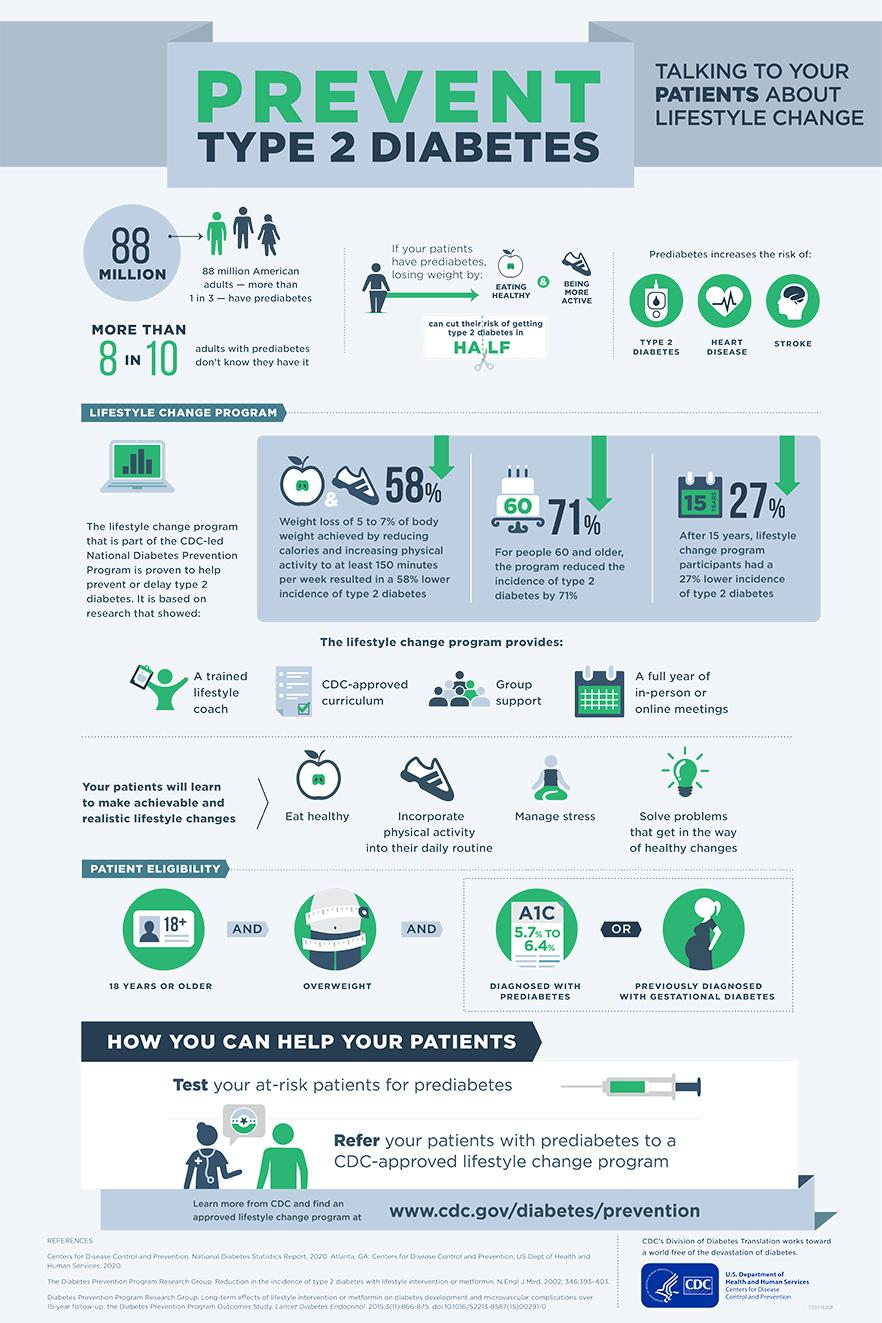Specify some key components in this picture. The A1C test is used to measure a person's average blood glucose levels over the previous three months, and the results of this test help to determine if a person has prediabetes. If a person has been diagnosed with prediabetes, the normal range of the A1C test is between 5.7% and 6.4%. A patient enrolled in the lifestyle change program may make a maximum of 4 changes. Approximately 58% of people can experience a reduction in the incidence of type 2 diabetes due to weight loss. Eating a healthy diet and being more physically active are two activities that can help individuals control their weight. Prediabetes poses a significant risk of developing type 2 diabetes, heart disease, and stroke. 